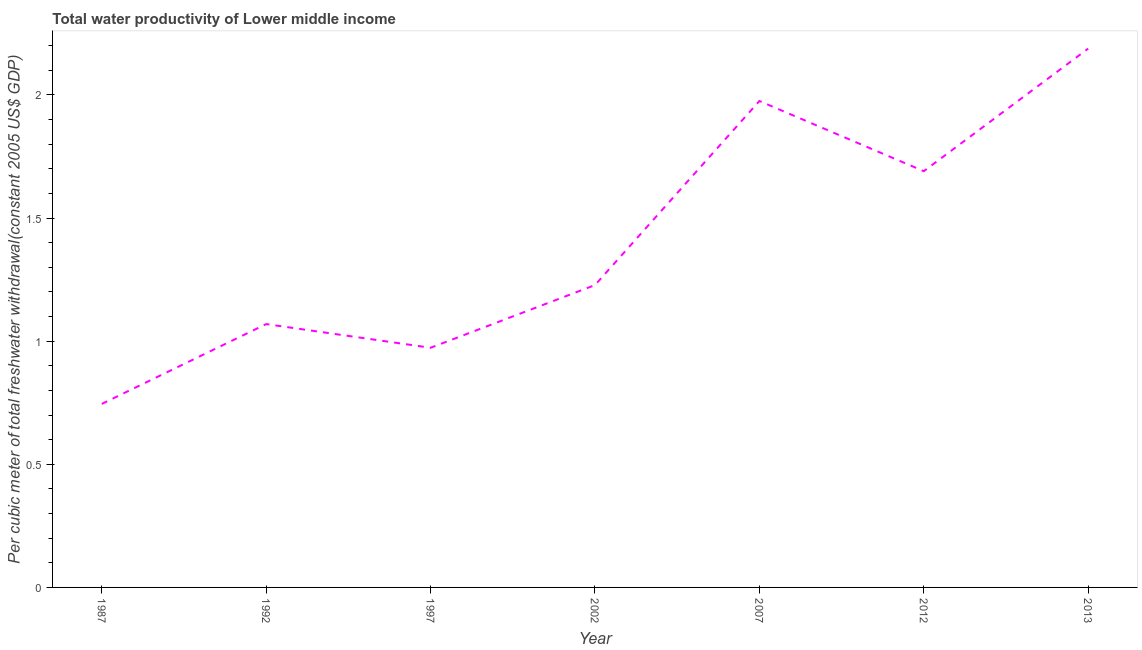What is the total water productivity in 2002?
Offer a very short reply. 1.23. Across all years, what is the maximum total water productivity?
Your answer should be compact. 2.19. Across all years, what is the minimum total water productivity?
Your answer should be compact. 0.75. In which year was the total water productivity maximum?
Ensure brevity in your answer.  2013. What is the sum of the total water productivity?
Make the answer very short. 9.87. What is the difference between the total water productivity in 2002 and 2012?
Make the answer very short. -0.46. What is the average total water productivity per year?
Your answer should be compact. 1.41. What is the median total water productivity?
Your response must be concise. 1.23. What is the ratio of the total water productivity in 1992 to that in 2007?
Give a very brief answer. 0.54. Is the total water productivity in 1992 less than that in 2012?
Offer a terse response. Yes. Is the difference between the total water productivity in 2012 and 2013 greater than the difference between any two years?
Offer a very short reply. No. What is the difference between the highest and the second highest total water productivity?
Offer a very short reply. 0.21. What is the difference between the highest and the lowest total water productivity?
Offer a terse response. 1.44. Does the total water productivity monotonically increase over the years?
Give a very brief answer. No. How many lines are there?
Offer a terse response. 1. Are the values on the major ticks of Y-axis written in scientific E-notation?
Give a very brief answer. No. Does the graph contain grids?
Ensure brevity in your answer.  No. What is the title of the graph?
Make the answer very short. Total water productivity of Lower middle income. What is the label or title of the Y-axis?
Give a very brief answer. Per cubic meter of total freshwater withdrawal(constant 2005 US$ GDP). What is the Per cubic meter of total freshwater withdrawal(constant 2005 US$ GDP) of 1987?
Ensure brevity in your answer.  0.75. What is the Per cubic meter of total freshwater withdrawal(constant 2005 US$ GDP) in 1992?
Keep it short and to the point. 1.07. What is the Per cubic meter of total freshwater withdrawal(constant 2005 US$ GDP) of 1997?
Provide a succinct answer. 0.97. What is the Per cubic meter of total freshwater withdrawal(constant 2005 US$ GDP) in 2002?
Your answer should be compact. 1.23. What is the Per cubic meter of total freshwater withdrawal(constant 2005 US$ GDP) in 2007?
Your answer should be very brief. 1.98. What is the Per cubic meter of total freshwater withdrawal(constant 2005 US$ GDP) in 2012?
Offer a terse response. 1.69. What is the Per cubic meter of total freshwater withdrawal(constant 2005 US$ GDP) of 2013?
Offer a terse response. 2.19. What is the difference between the Per cubic meter of total freshwater withdrawal(constant 2005 US$ GDP) in 1987 and 1992?
Ensure brevity in your answer.  -0.32. What is the difference between the Per cubic meter of total freshwater withdrawal(constant 2005 US$ GDP) in 1987 and 1997?
Provide a succinct answer. -0.23. What is the difference between the Per cubic meter of total freshwater withdrawal(constant 2005 US$ GDP) in 1987 and 2002?
Keep it short and to the point. -0.48. What is the difference between the Per cubic meter of total freshwater withdrawal(constant 2005 US$ GDP) in 1987 and 2007?
Make the answer very short. -1.23. What is the difference between the Per cubic meter of total freshwater withdrawal(constant 2005 US$ GDP) in 1987 and 2012?
Offer a terse response. -0.95. What is the difference between the Per cubic meter of total freshwater withdrawal(constant 2005 US$ GDP) in 1987 and 2013?
Your response must be concise. -1.44. What is the difference between the Per cubic meter of total freshwater withdrawal(constant 2005 US$ GDP) in 1992 and 1997?
Offer a very short reply. 0.1. What is the difference between the Per cubic meter of total freshwater withdrawal(constant 2005 US$ GDP) in 1992 and 2002?
Your answer should be compact. -0.16. What is the difference between the Per cubic meter of total freshwater withdrawal(constant 2005 US$ GDP) in 1992 and 2007?
Your answer should be very brief. -0.91. What is the difference between the Per cubic meter of total freshwater withdrawal(constant 2005 US$ GDP) in 1992 and 2012?
Provide a short and direct response. -0.62. What is the difference between the Per cubic meter of total freshwater withdrawal(constant 2005 US$ GDP) in 1992 and 2013?
Provide a succinct answer. -1.12. What is the difference between the Per cubic meter of total freshwater withdrawal(constant 2005 US$ GDP) in 1997 and 2002?
Provide a short and direct response. -0.25. What is the difference between the Per cubic meter of total freshwater withdrawal(constant 2005 US$ GDP) in 1997 and 2007?
Provide a succinct answer. -1. What is the difference between the Per cubic meter of total freshwater withdrawal(constant 2005 US$ GDP) in 1997 and 2012?
Offer a very short reply. -0.72. What is the difference between the Per cubic meter of total freshwater withdrawal(constant 2005 US$ GDP) in 1997 and 2013?
Offer a very short reply. -1.22. What is the difference between the Per cubic meter of total freshwater withdrawal(constant 2005 US$ GDP) in 2002 and 2007?
Ensure brevity in your answer.  -0.75. What is the difference between the Per cubic meter of total freshwater withdrawal(constant 2005 US$ GDP) in 2002 and 2012?
Make the answer very short. -0.46. What is the difference between the Per cubic meter of total freshwater withdrawal(constant 2005 US$ GDP) in 2002 and 2013?
Ensure brevity in your answer.  -0.96. What is the difference between the Per cubic meter of total freshwater withdrawal(constant 2005 US$ GDP) in 2007 and 2012?
Your response must be concise. 0.28. What is the difference between the Per cubic meter of total freshwater withdrawal(constant 2005 US$ GDP) in 2007 and 2013?
Make the answer very short. -0.21. What is the difference between the Per cubic meter of total freshwater withdrawal(constant 2005 US$ GDP) in 2012 and 2013?
Your answer should be very brief. -0.5. What is the ratio of the Per cubic meter of total freshwater withdrawal(constant 2005 US$ GDP) in 1987 to that in 1992?
Offer a terse response. 0.7. What is the ratio of the Per cubic meter of total freshwater withdrawal(constant 2005 US$ GDP) in 1987 to that in 1997?
Provide a short and direct response. 0.77. What is the ratio of the Per cubic meter of total freshwater withdrawal(constant 2005 US$ GDP) in 1987 to that in 2002?
Give a very brief answer. 0.61. What is the ratio of the Per cubic meter of total freshwater withdrawal(constant 2005 US$ GDP) in 1987 to that in 2007?
Make the answer very short. 0.38. What is the ratio of the Per cubic meter of total freshwater withdrawal(constant 2005 US$ GDP) in 1987 to that in 2012?
Your answer should be compact. 0.44. What is the ratio of the Per cubic meter of total freshwater withdrawal(constant 2005 US$ GDP) in 1987 to that in 2013?
Offer a very short reply. 0.34. What is the ratio of the Per cubic meter of total freshwater withdrawal(constant 2005 US$ GDP) in 1992 to that in 1997?
Ensure brevity in your answer.  1.1. What is the ratio of the Per cubic meter of total freshwater withdrawal(constant 2005 US$ GDP) in 1992 to that in 2002?
Ensure brevity in your answer.  0.87. What is the ratio of the Per cubic meter of total freshwater withdrawal(constant 2005 US$ GDP) in 1992 to that in 2007?
Provide a short and direct response. 0.54. What is the ratio of the Per cubic meter of total freshwater withdrawal(constant 2005 US$ GDP) in 1992 to that in 2012?
Make the answer very short. 0.63. What is the ratio of the Per cubic meter of total freshwater withdrawal(constant 2005 US$ GDP) in 1992 to that in 2013?
Ensure brevity in your answer.  0.49. What is the ratio of the Per cubic meter of total freshwater withdrawal(constant 2005 US$ GDP) in 1997 to that in 2002?
Ensure brevity in your answer.  0.79. What is the ratio of the Per cubic meter of total freshwater withdrawal(constant 2005 US$ GDP) in 1997 to that in 2007?
Your answer should be compact. 0.49. What is the ratio of the Per cubic meter of total freshwater withdrawal(constant 2005 US$ GDP) in 1997 to that in 2012?
Keep it short and to the point. 0.58. What is the ratio of the Per cubic meter of total freshwater withdrawal(constant 2005 US$ GDP) in 1997 to that in 2013?
Your answer should be very brief. 0.45. What is the ratio of the Per cubic meter of total freshwater withdrawal(constant 2005 US$ GDP) in 2002 to that in 2007?
Offer a terse response. 0.62. What is the ratio of the Per cubic meter of total freshwater withdrawal(constant 2005 US$ GDP) in 2002 to that in 2012?
Give a very brief answer. 0.73. What is the ratio of the Per cubic meter of total freshwater withdrawal(constant 2005 US$ GDP) in 2002 to that in 2013?
Your response must be concise. 0.56. What is the ratio of the Per cubic meter of total freshwater withdrawal(constant 2005 US$ GDP) in 2007 to that in 2012?
Offer a very short reply. 1.17. What is the ratio of the Per cubic meter of total freshwater withdrawal(constant 2005 US$ GDP) in 2007 to that in 2013?
Your response must be concise. 0.9. What is the ratio of the Per cubic meter of total freshwater withdrawal(constant 2005 US$ GDP) in 2012 to that in 2013?
Provide a short and direct response. 0.77. 